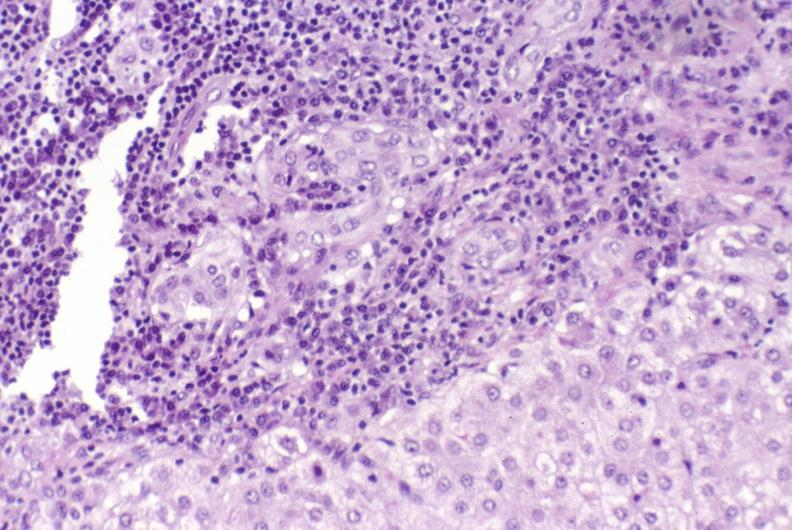does this image show primary biliary cirrhosis?
Answer the question using a single word or phrase. Yes 